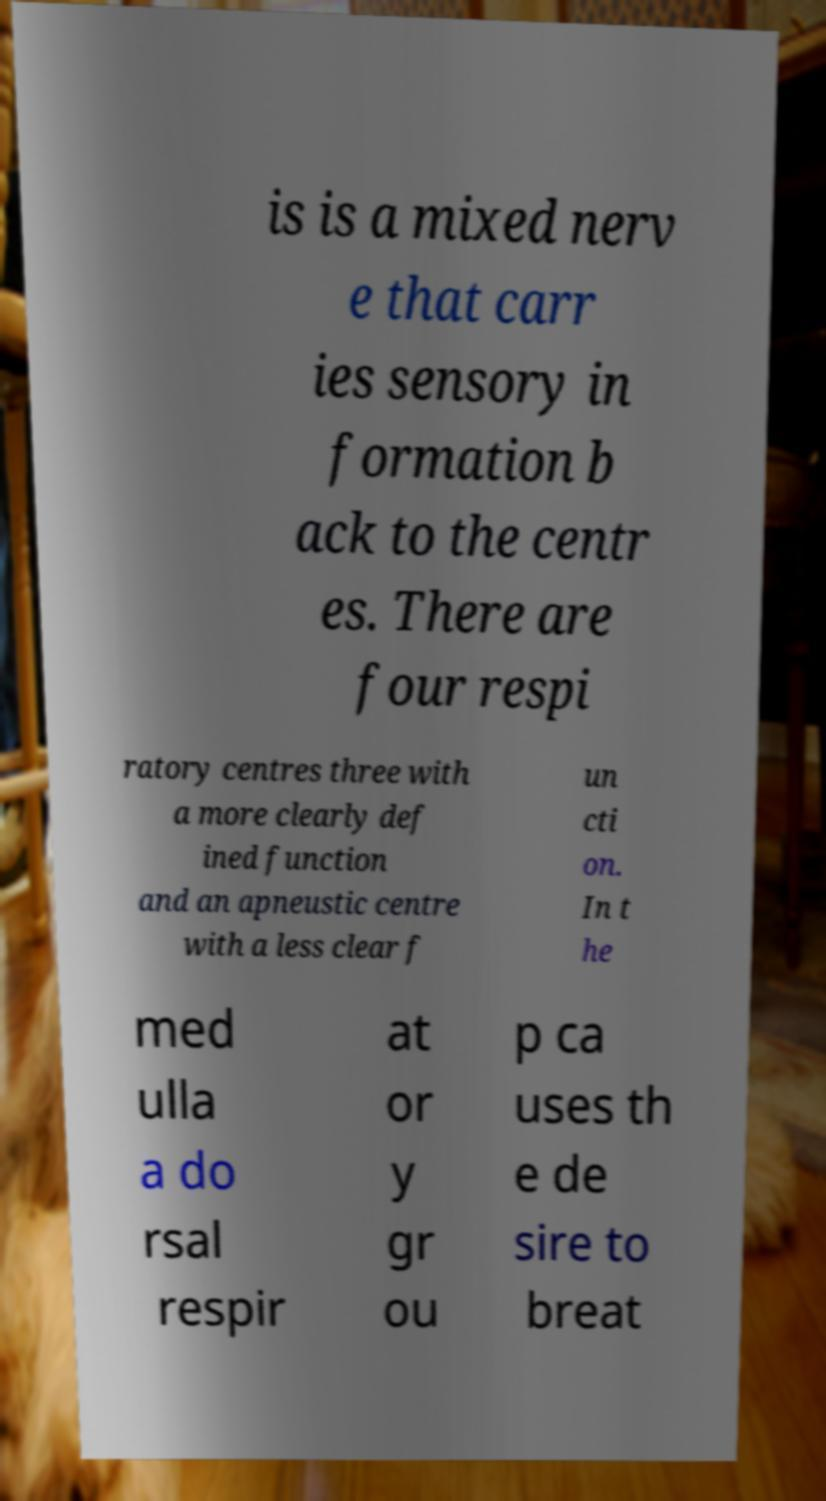For documentation purposes, I need the text within this image transcribed. Could you provide that? is is a mixed nerv e that carr ies sensory in formation b ack to the centr es. There are four respi ratory centres three with a more clearly def ined function and an apneustic centre with a less clear f un cti on. In t he med ulla a do rsal respir at or y gr ou p ca uses th e de sire to breat 